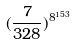Convert formula to latex. <formula><loc_0><loc_0><loc_500><loc_500>( \frac { 7 } { 3 2 8 } ) ^ { 8 ^ { 1 5 3 } }</formula> 